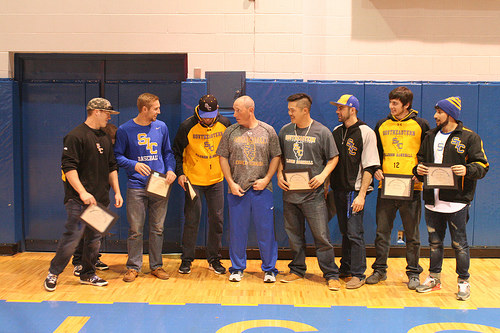<image>
Can you confirm if the door is behind the man? Yes. From this viewpoint, the door is positioned behind the man, with the man partially or fully occluding the door. 